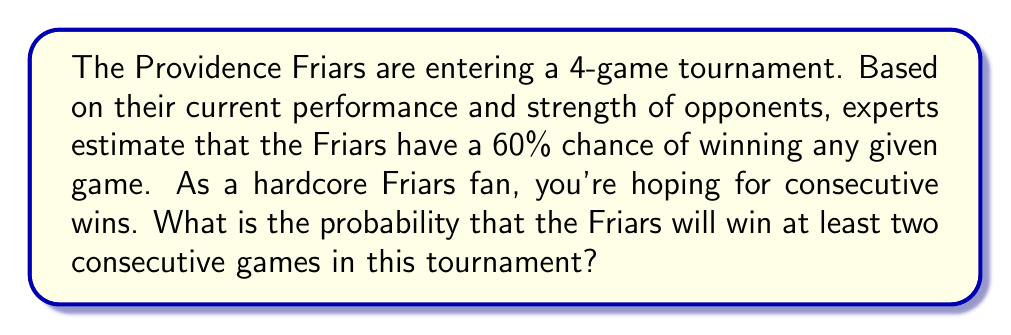Can you answer this question? Let's approach this step-by-step:

1) First, we need to identify all the possible ways the Friars can win at least two consecutive games in a 4-game tournament. The favorable outcomes are:
   - WWWW (4 wins)
   - WWWL (3 wins)
   - LWWW (3 wins)
   - WWLL (2 consecutive wins)
   - LWWL (2 consecutive wins)

2) Now, let's calculate the probability of each outcome:
   - P(W) = 0.6 (probability of winning a single game)
   - P(L) = 1 - 0.6 = 0.4 (probability of losing a single game)

3) Probability of each favorable outcome:
   - P(WWWW) = $0.6^4 = 0.1296$
   - P(WWWL) = $0.6^3 * 0.4 = 0.0864$
   - P(LWWW) = $0.4 * 0.6^3 = 0.0864$
   - P(WWLL) = $0.6^2 * 0.4^2 = 0.0576$
   - P(LWWL) = $0.4 * 0.6^2 * 0.4 = 0.0576$

4) The total probability is the sum of all these probabilities:

   $$P(\text{at least two consecutive wins}) = 0.1296 + 0.0864 + 0.0864 + 0.0576 + 0.0576 = 0.4176$$

5) Therefore, the probability of the Friars winning at least two consecutive games in this tournament is approximately 0.4176 or 41.76%.
Answer: The probability that the Providence Friars will win at least two consecutive games in the 4-game tournament is approximately $0.4176$ or $41.76\%$. 